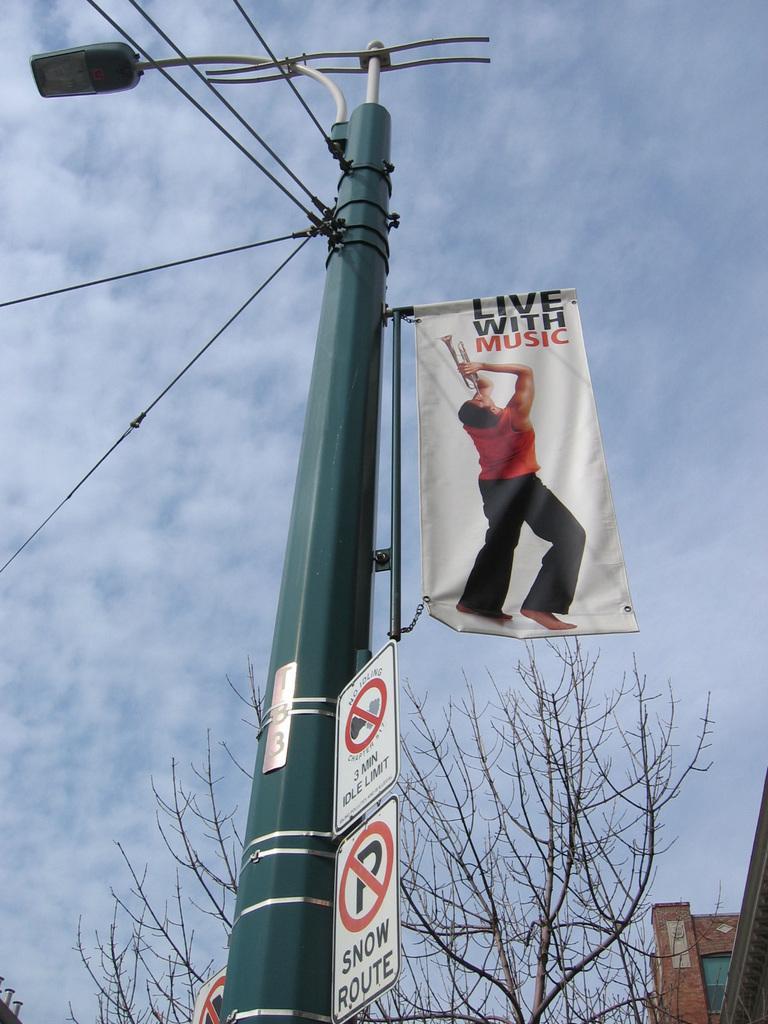Please provide a concise description of this image. In this image, there is an outside view. In the foreground, there is a street pole contains sign boards and banner. There is a tree at the bottom of the image. In the background, there is sky. 